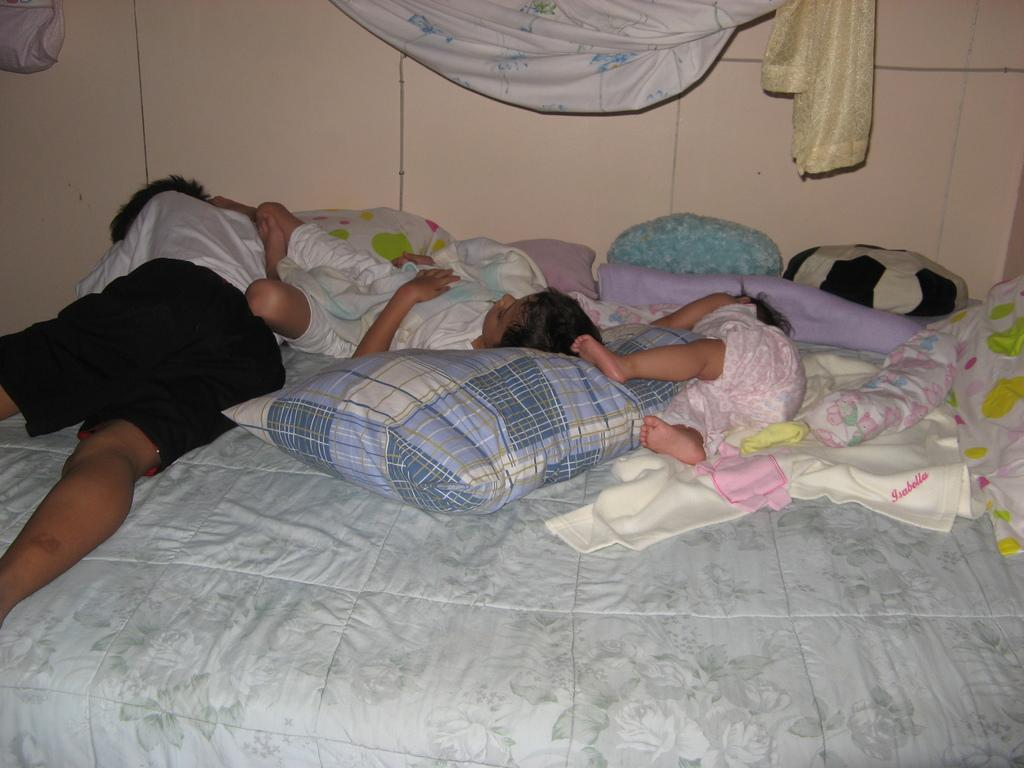What type of room is shown in the image? The image appears to depict a bedroom. How many people are sleeping in the bedroom? There are three people sleeping on a bed in the image. What can be seen in the background of the bedroom? There is a cream-colored wardrobe in the background. What type of marble is used for the flooring in the bedroom? There is no information about the flooring in the image, and therefore no mention of marble. 